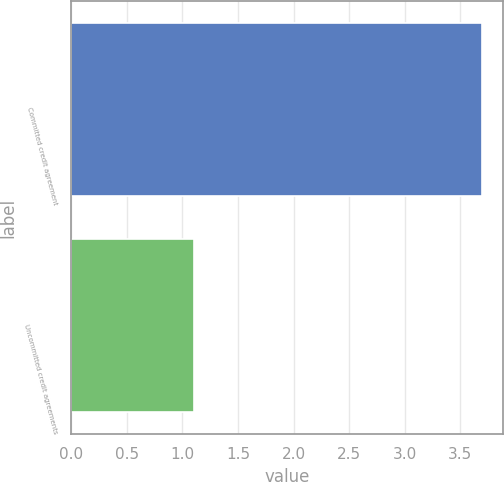<chart> <loc_0><loc_0><loc_500><loc_500><bar_chart><fcel>Committed credit agreement<fcel>Uncommitted credit agreements<nl><fcel>3.7<fcel>1.1<nl></chart> 